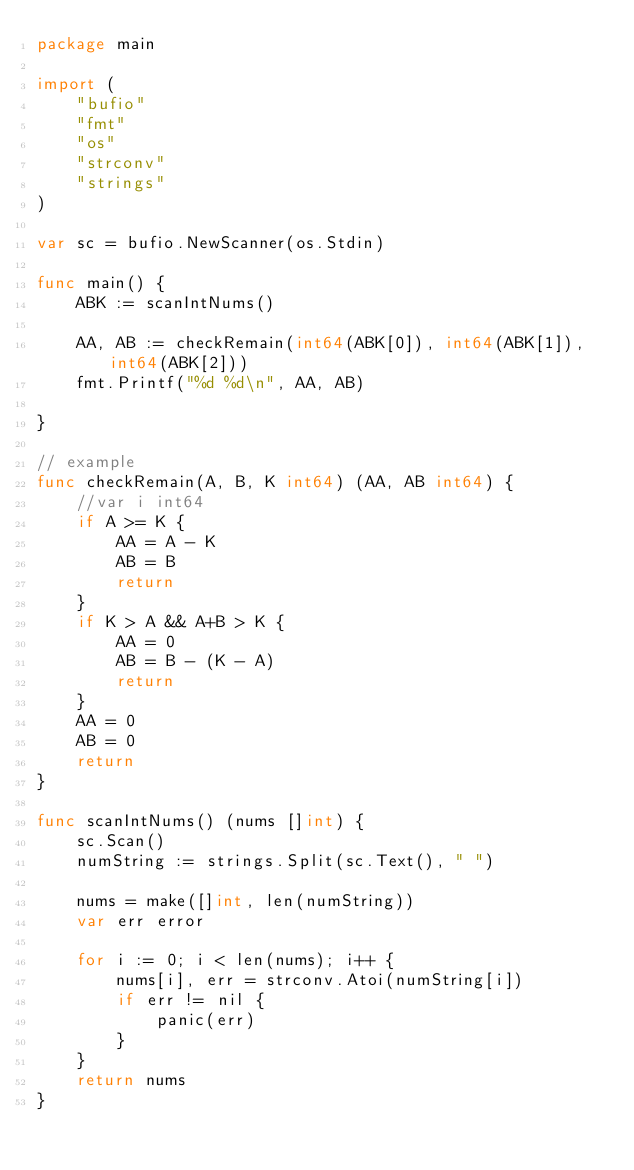Convert code to text. <code><loc_0><loc_0><loc_500><loc_500><_Go_>package main

import (
	"bufio"
	"fmt"
	"os"
	"strconv"
	"strings"
)

var sc = bufio.NewScanner(os.Stdin)

func main() {
	ABK := scanIntNums()

	AA, AB := checkRemain(int64(ABK[0]), int64(ABK[1]), int64(ABK[2]))
	fmt.Printf("%d %d\n", AA, AB)

}

// example
func checkRemain(A, B, K int64) (AA, AB int64) {
	//var i int64
	if A >= K {
		AA = A - K
		AB = B
		return
	}
	if K > A && A+B > K {
		AA = 0
		AB = B - (K - A)
		return
	}
	AA = 0
	AB = 0
	return
}

func scanIntNums() (nums []int) {
	sc.Scan()
	numString := strings.Split(sc.Text(), " ")

	nums = make([]int, len(numString))
	var err error

	for i := 0; i < len(nums); i++ {
		nums[i], err = strconv.Atoi(numString[i])
		if err != nil {
			panic(err)
		}
	}
	return nums
}</code> 